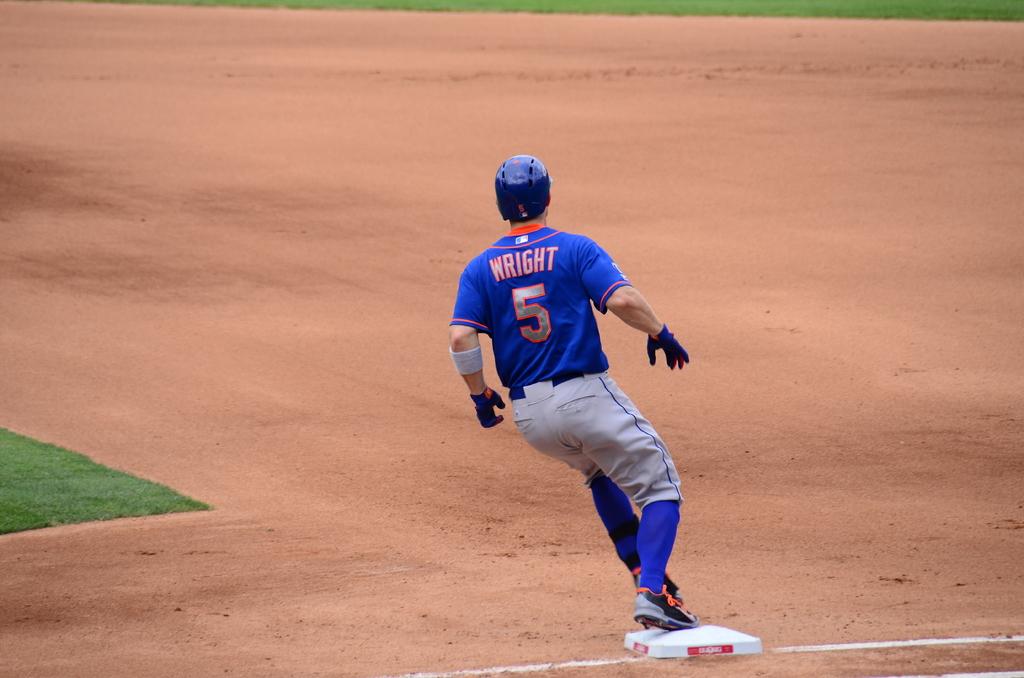What is the players number?
Ensure brevity in your answer.  5. What's the players name?
Offer a terse response. Wright. 